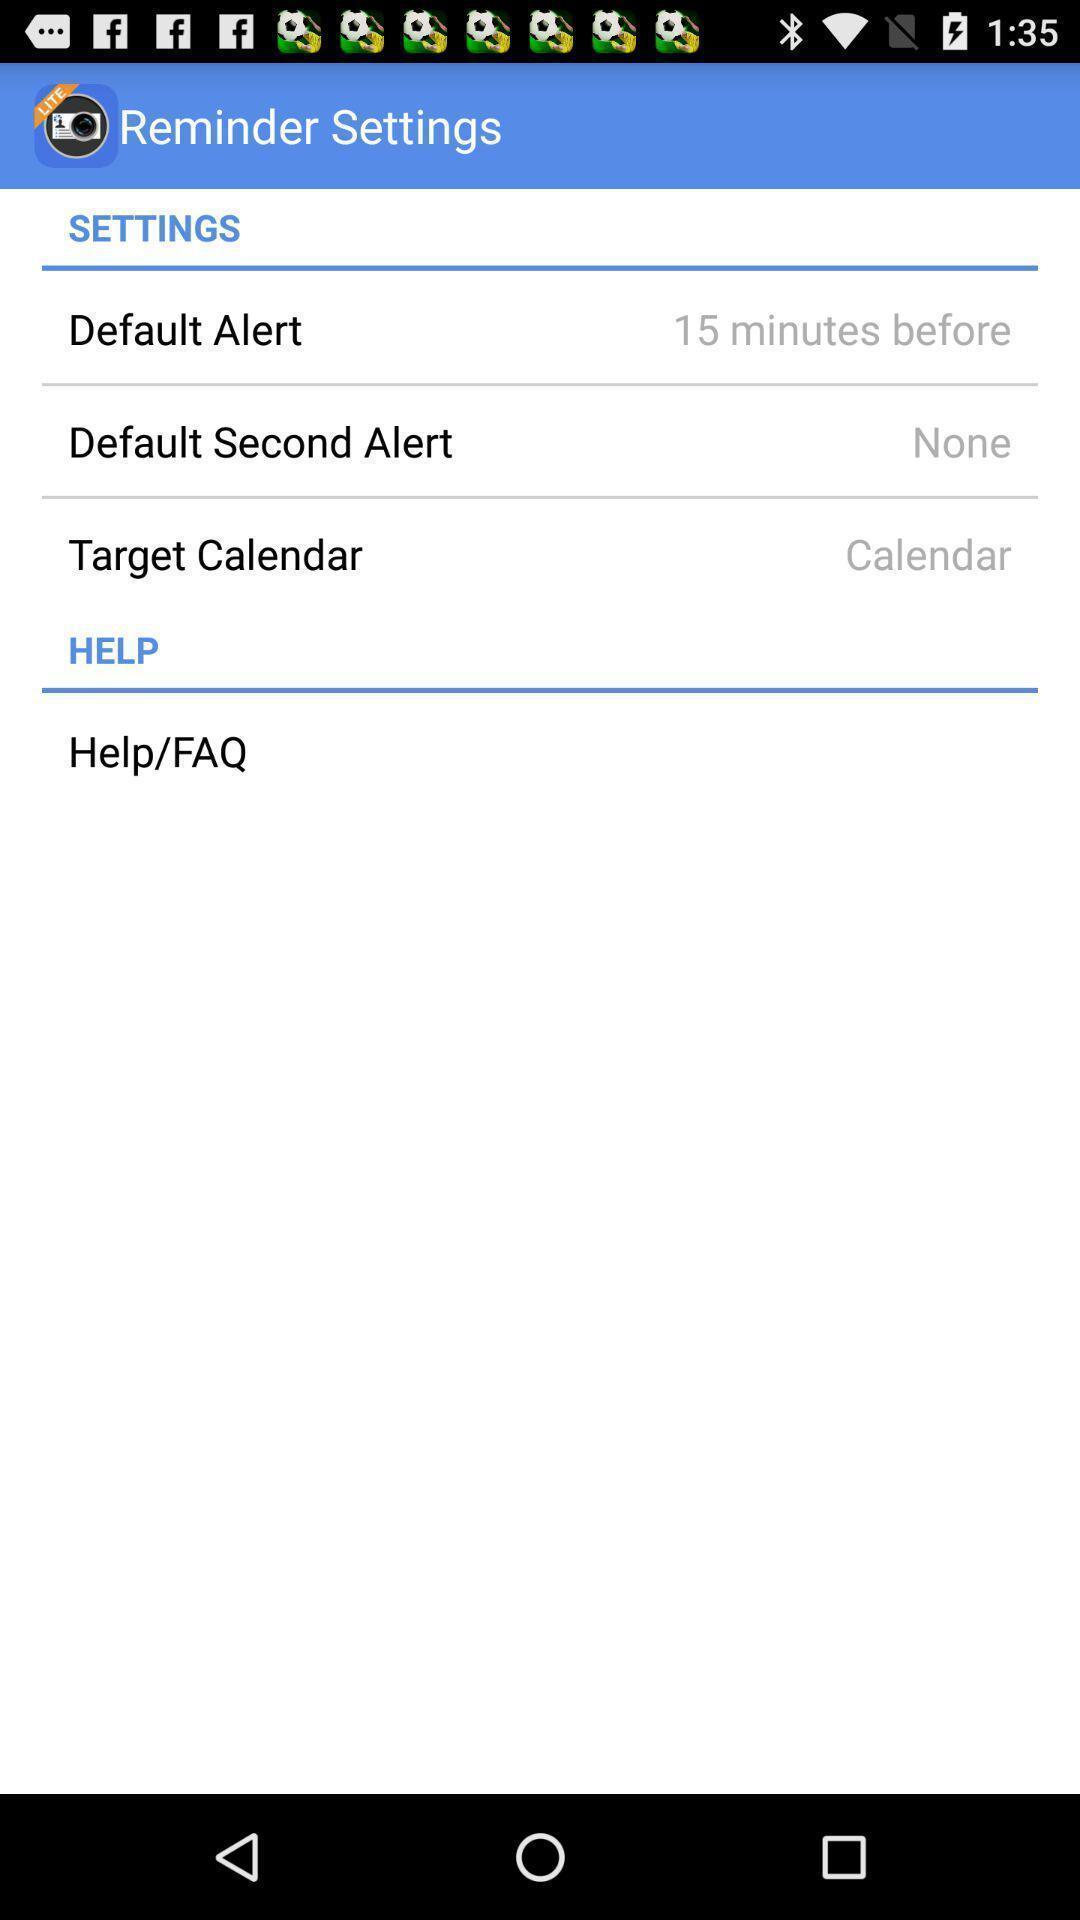Please provide a description for this image. Screen displaying the settings of a reminder. 